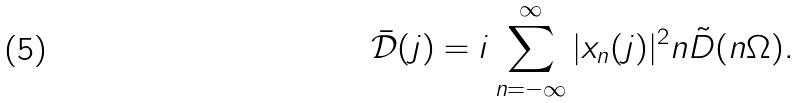<formula> <loc_0><loc_0><loc_500><loc_500>\bar { \mathcal { D } } ( j ) = i \sum _ { n = - \infty } ^ { \infty } | x _ { n } ( j ) | ^ { 2 } n \tilde { D } ( n \Omega ) .</formula> 